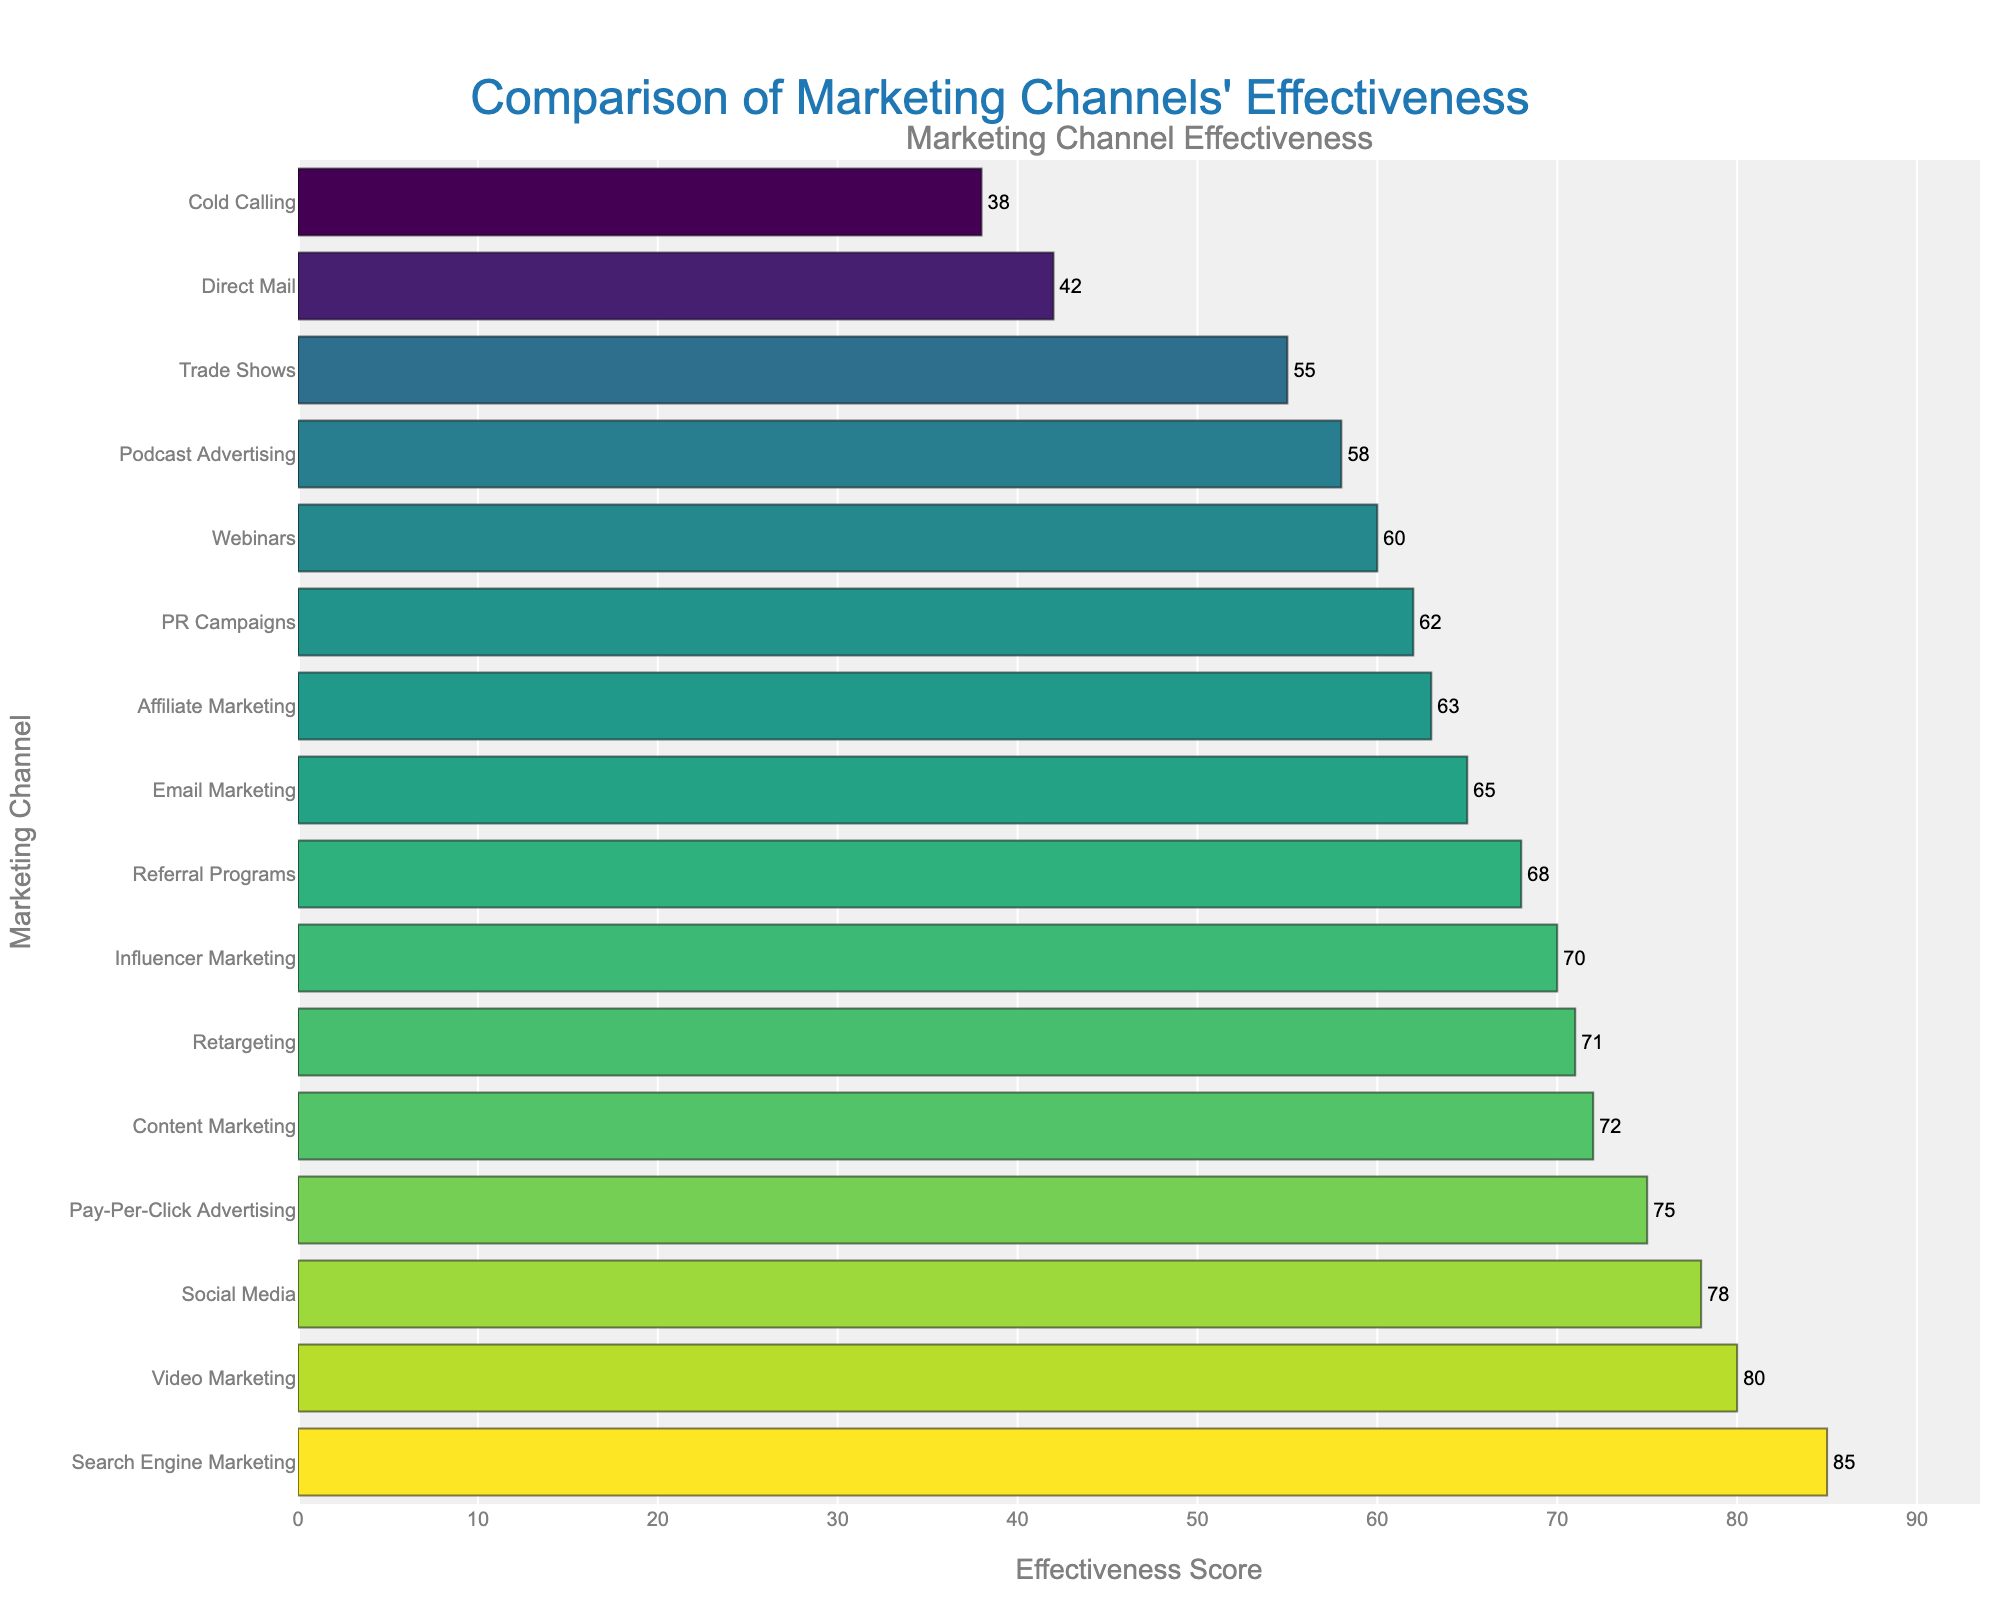Which marketing channel has the highest effectiveness score? The bar chart shows that Search Engine Marketing has the longest bar, indicating it has the highest effectiveness score.
Answer: Search Engine Marketing What is the difference in effectiveness score between Video Marketing and Direct Mail? According to the figure, Video Marketing has a score of 80 and Direct Mail has a score of 42. The difference between them is 80 - 42 = 38.
Answer: 38 Which marketing channel has a higher effectiveness score, Content Marketing or Podcasts Advertising? Content Marketing has a score of 72, while Podcast Advertising has a score of 58, so Content Marketing has a higher effectiveness score.
Answer: Content Marketing How many marketing channels have an effectiveness score greater than 70? From the figure, Social Media, Content Marketing, Search Engine Marketing, Influencer Marketing, Pay-Per-Click Advertising, and Video Marketing all have scores greater than 70. These are 6 channels.
Answer: 6 What is the average effectiveness score of Email Marketing, Webinars, and PR Campaigns? Email Marketing has a score of 65, Webinars have a score of 60, and PR Campaigns have a score of 62. The average is (65 + 60 + 62) / 3 = 62.33.
Answer: 62.33 